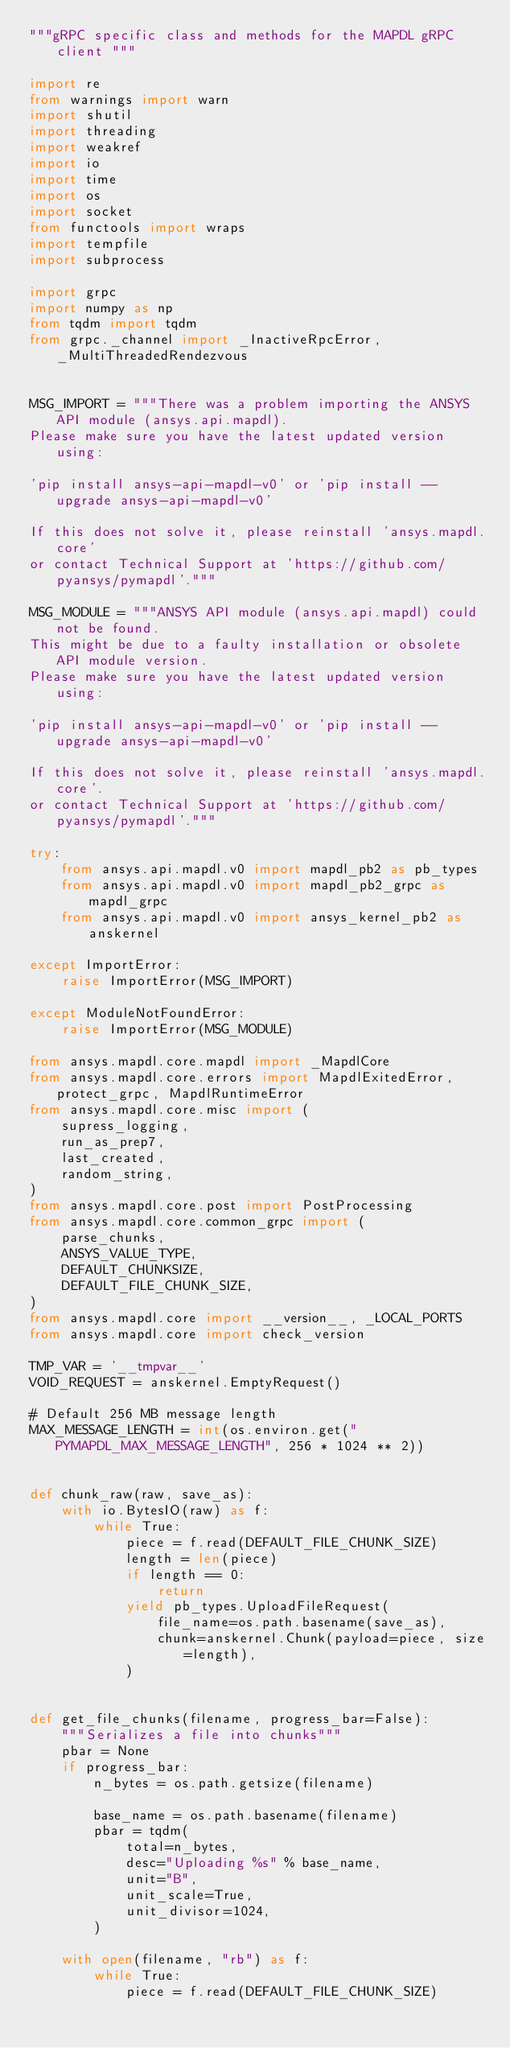<code> <loc_0><loc_0><loc_500><loc_500><_Python_>"""gRPC specific class and methods for the MAPDL gRPC client """

import re
from warnings import warn
import shutil
import threading
import weakref
import io
import time
import os
import socket
from functools import wraps
import tempfile
import subprocess

import grpc
import numpy as np
from tqdm import tqdm
from grpc._channel import _InactiveRpcError, _MultiThreadedRendezvous


MSG_IMPORT = """There was a problem importing the ANSYS API module (ansys.api.mapdl).
Please make sure you have the latest updated version using:

'pip install ansys-api-mapdl-v0' or 'pip install --upgrade ansys-api-mapdl-v0'

If this does not solve it, please reinstall 'ansys.mapdl.core'
or contact Technical Support at 'https://github.com/pyansys/pymapdl'."""

MSG_MODULE = """ANSYS API module (ansys.api.mapdl) could not be found.
This might be due to a faulty installation or obsolete API module version.
Please make sure you have the latest updated version using:

'pip install ansys-api-mapdl-v0' or 'pip install --upgrade ansys-api-mapdl-v0'

If this does not solve it, please reinstall 'ansys.mapdl.core'.
or contact Technical Support at 'https://github.com/pyansys/pymapdl'."""

try:
    from ansys.api.mapdl.v0 import mapdl_pb2 as pb_types
    from ansys.api.mapdl.v0 import mapdl_pb2_grpc as mapdl_grpc
    from ansys.api.mapdl.v0 import ansys_kernel_pb2 as anskernel

except ImportError:
    raise ImportError(MSG_IMPORT)

except ModuleNotFoundError:
    raise ImportError(MSG_MODULE)

from ansys.mapdl.core.mapdl import _MapdlCore
from ansys.mapdl.core.errors import MapdlExitedError, protect_grpc, MapdlRuntimeError
from ansys.mapdl.core.misc import (
    supress_logging,
    run_as_prep7,
    last_created,
    random_string,
)
from ansys.mapdl.core.post import PostProcessing
from ansys.mapdl.core.common_grpc import (
    parse_chunks,
    ANSYS_VALUE_TYPE,
    DEFAULT_CHUNKSIZE,
    DEFAULT_FILE_CHUNK_SIZE,
)
from ansys.mapdl.core import __version__, _LOCAL_PORTS
from ansys.mapdl.core import check_version

TMP_VAR = '__tmpvar__'
VOID_REQUEST = anskernel.EmptyRequest()

# Default 256 MB message length
MAX_MESSAGE_LENGTH = int(os.environ.get("PYMAPDL_MAX_MESSAGE_LENGTH", 256 * 1024 ** 2))


def chunk_raw(raw, save_as):
    with io.BytesIO(raw) as f:
        while True:
            piece = f.read(DEFAULT_FILE_CHUNK_SIZE)
            length = len(piece)
            if length == 0:
                return
            yield pb_types.UploadFileRequest(
                file_name=os.path.basename(save_as),
                chunk=anskernel.Chunk(payload=piece, size=length),
            )


def get_file_chunks(filename, progress_bar=False):
    """Serializes a file into chunks"""
    pbar = None
    if progress_bar:
        n_bytes = os.path.getsize(filename)

        base_name = os.path.basename(filename)
        pbar = tqdm(
            total=n_bytes,
            desc="Uploading %s" % base_name,
            unit="B",
            unit_scale=True,
            unit_divisor=1024,
        )

    with open(filename, "rb") as f:
        while True:
            piece = f.read(DEFAULT_FILE_CHUNK_SIZE)</code> 